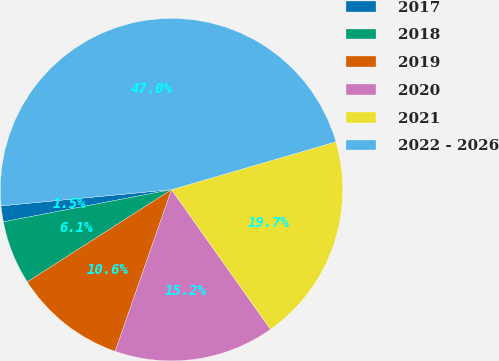Convert chart to OTSL. <chart><loc_0><loc_0><loc_500><loc_500><pie_chart><fcel>2017<fcel>2018<fcel>2019<fcel>2020<fcel>2021<fcel>2022 - 2026<nl><fcel>1.5%<fcel>6.05%<fcel>10.6%<fcel>15.15%<fcel>19.7%<fcel>47.0%<nl></chart> 